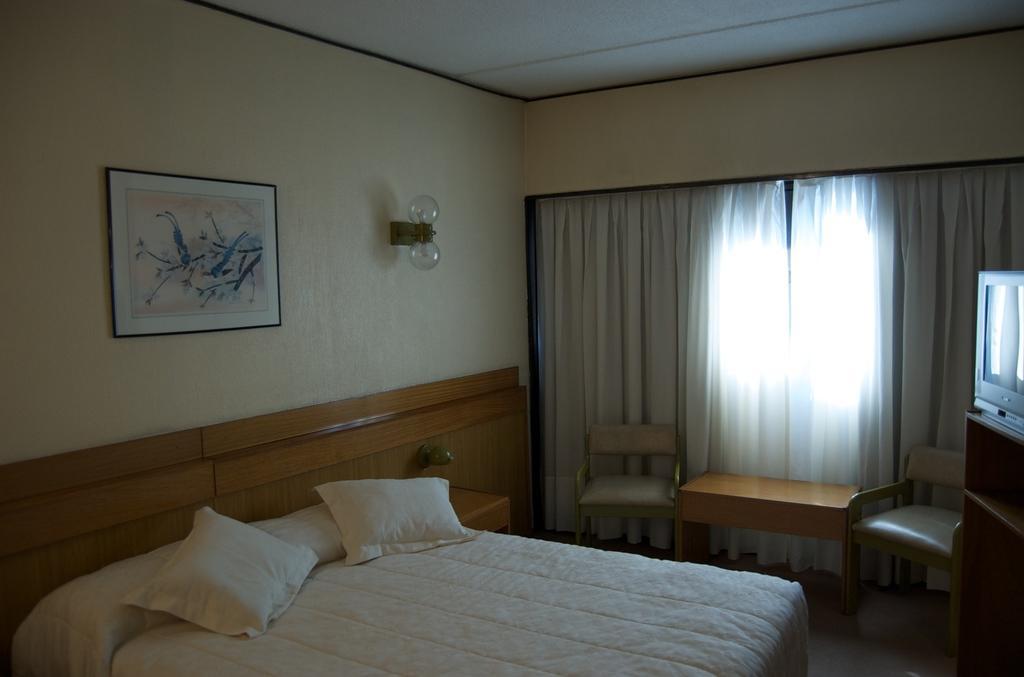In one or two sentences, can you explain what this image depicts? In this image I can see a bed, on the bed I can see two pillows in white color. In front I can see a chair, I can also see a frame attached to the wall and the wall is in cream. 